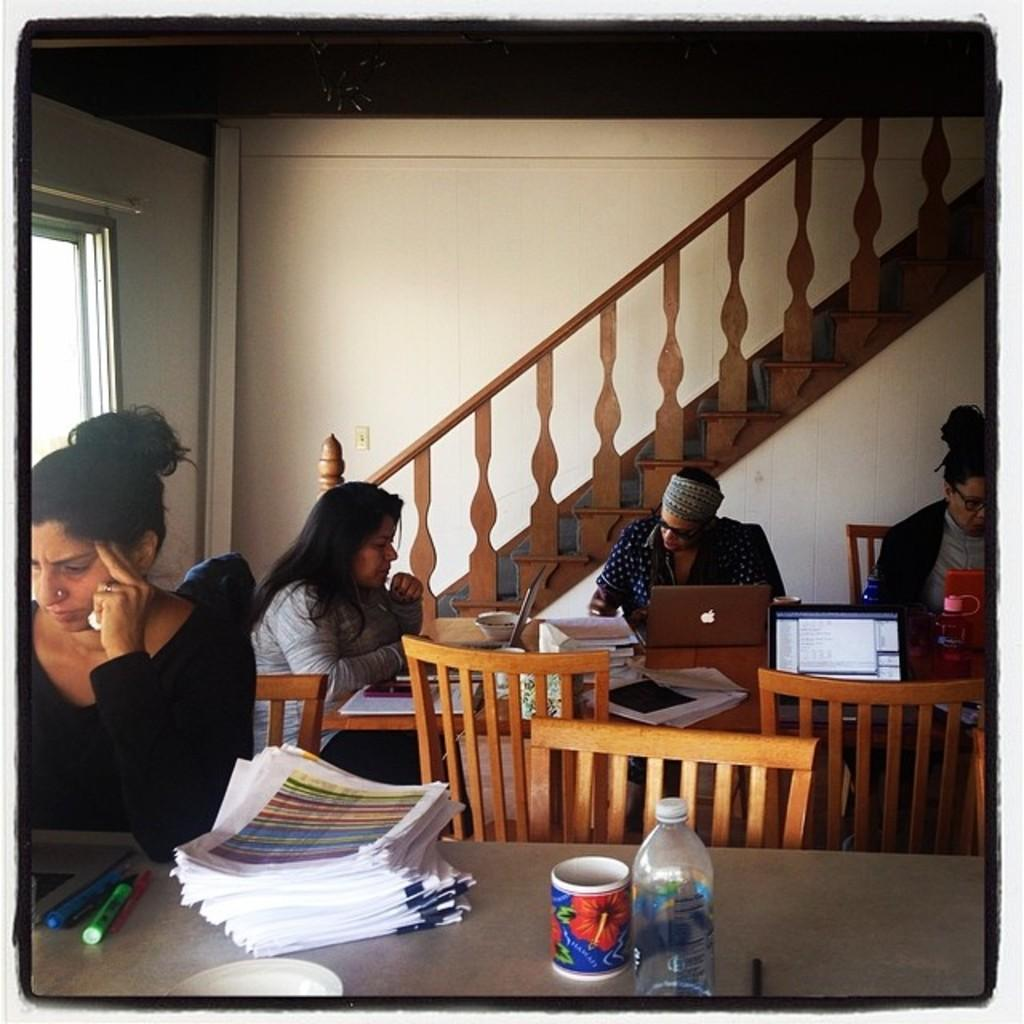How many people are present in the image? There are four people in the image. What are the people doing in the image? The people are sitting in chairs and working with their laptops. How are the chairs arranged in the image? The chairs are positioned around a table. What type of profit can be seen being generated by the plantation in the image? There is no plantation present in the image, and therefore no profit can be observed. How many men are visible in the image? The image does not specify the gender of the people, so it cannot be determined how many men are visible. 